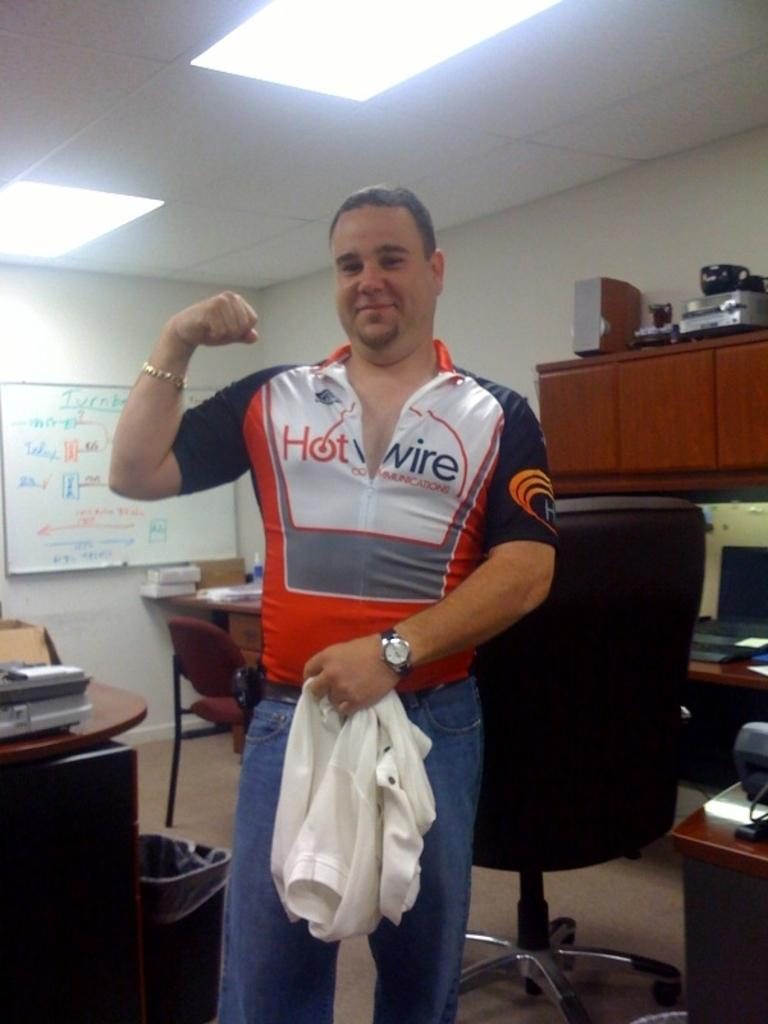<image>
Describe the image concisely. the name Hotwire that is on a person's shirt 